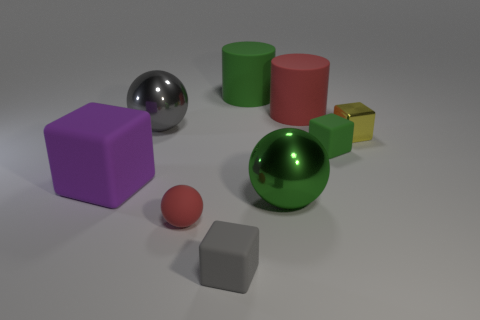Subtract 0 brown cubes. How many objects are left? 9 Subtract all blocks. How many objects are left? 5 Subtract 1 blocks. How many blocks are left? 3 Subtract all purple cubes. Subtract all yellow balls. How many cubes are left? 3 Subtract all brown spheres. How many purple blocks are left? 1 Subtract all tiny rubber objects. Subtract all small red things. How many objects are left? 5 Add 7 small rubber blocks. How many small rubber blocks are left? 9 Add 5 gray shiny balls. How many gray shiny balls exist? 6 Add 1 big metallic objects. How many objects exist? 10 Subtract all green balls. How many balls are left? 2 